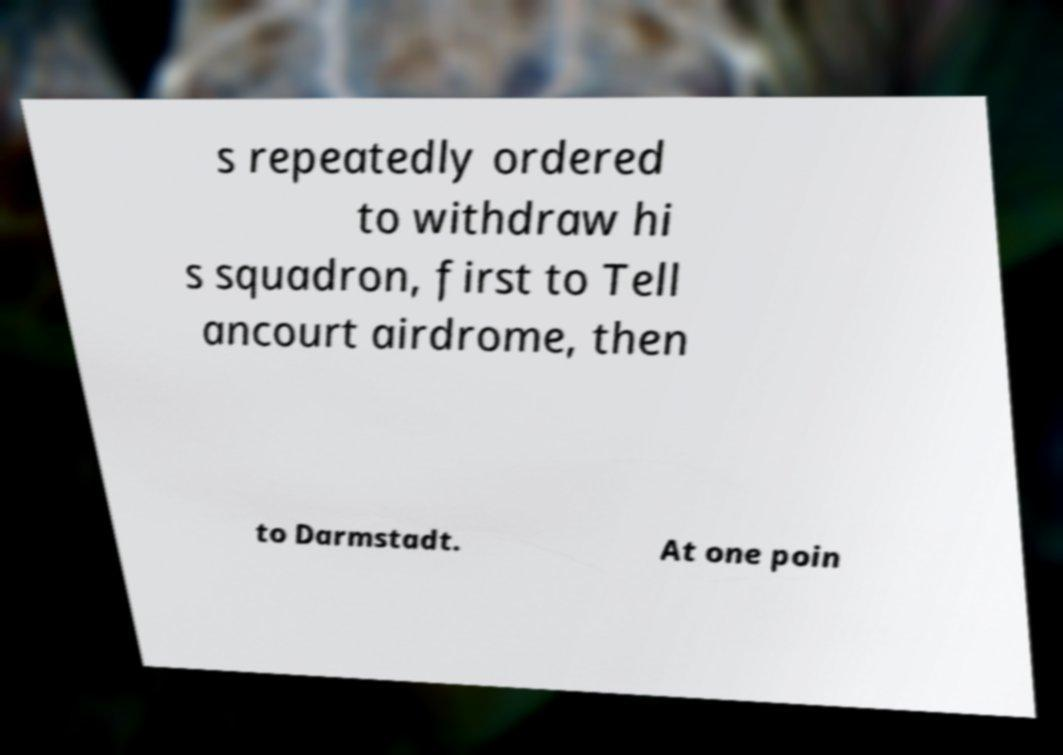What messages or text are displayed in this image? I need them in a readable, typed format. s repeatedly ordered to withdraw hi s squadron, first to Tell ancourt airdrome, then to Darmstadt. At one poin 